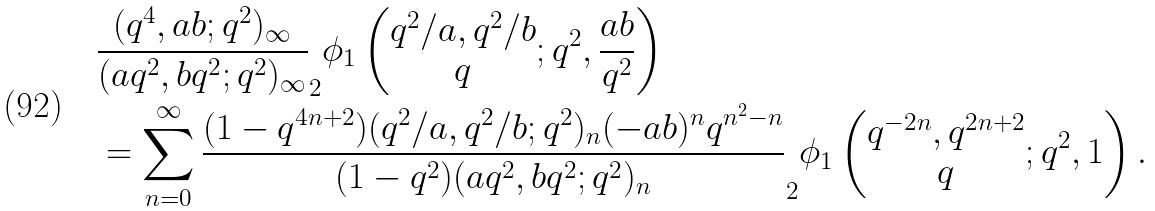Convert formula to latex. <formula><loc_0><loc_0><loc_500><loc_500>& \frac { ( q ^ { 4 } , a b ; q ^ { 2 } ) _ { \infty } } { ( a q ^ { 2 } , b q ^ { 2 } ; q ^ { 2 } ) _ { \infty } } _ { 2 } \phi _ { 1 } \left ( \begin{matrix} q ^ { 2 } / a , q ^ { 2 } / b \\ q \end{matrix} ; q ^ { 2 } , \frac { a b } { q ^ { 2 } } \right ) \\ & = \sum _ { n = 0 } ^ { \infty } \frac { ( 1 - q ^ { 4 n + 2 } ) ( q ^ { 2 } / a , q ^ { 2 } / b ; q ^ { 2 } ) _ { n } ( - a b ) ^ { n } q ^ { n ^ { 2 } - n } } { ( 1 - q ^ { 2 } ) ( a q ^ { 2 } , b q ^ { 2 } ; q ^ { 2 } ) _ { n } } _ { 2 } \phi _ { 1 } \left ( \begin{matrix} q ^ { - 2 n } , q ^ { 2 n + 2 } \\ q \end{matrix} ; q ^ { 2 } , 1 \right ) .</formula> 